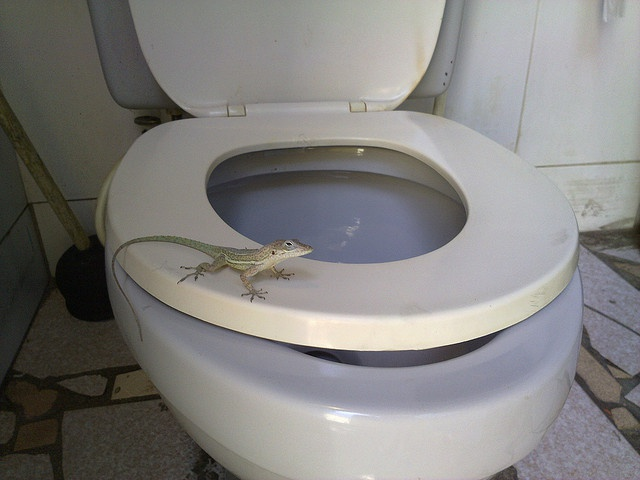Describe the objects in this image and their specific colors. I can see a toilet in gray, darkgray, and lightgray tones in this image. 